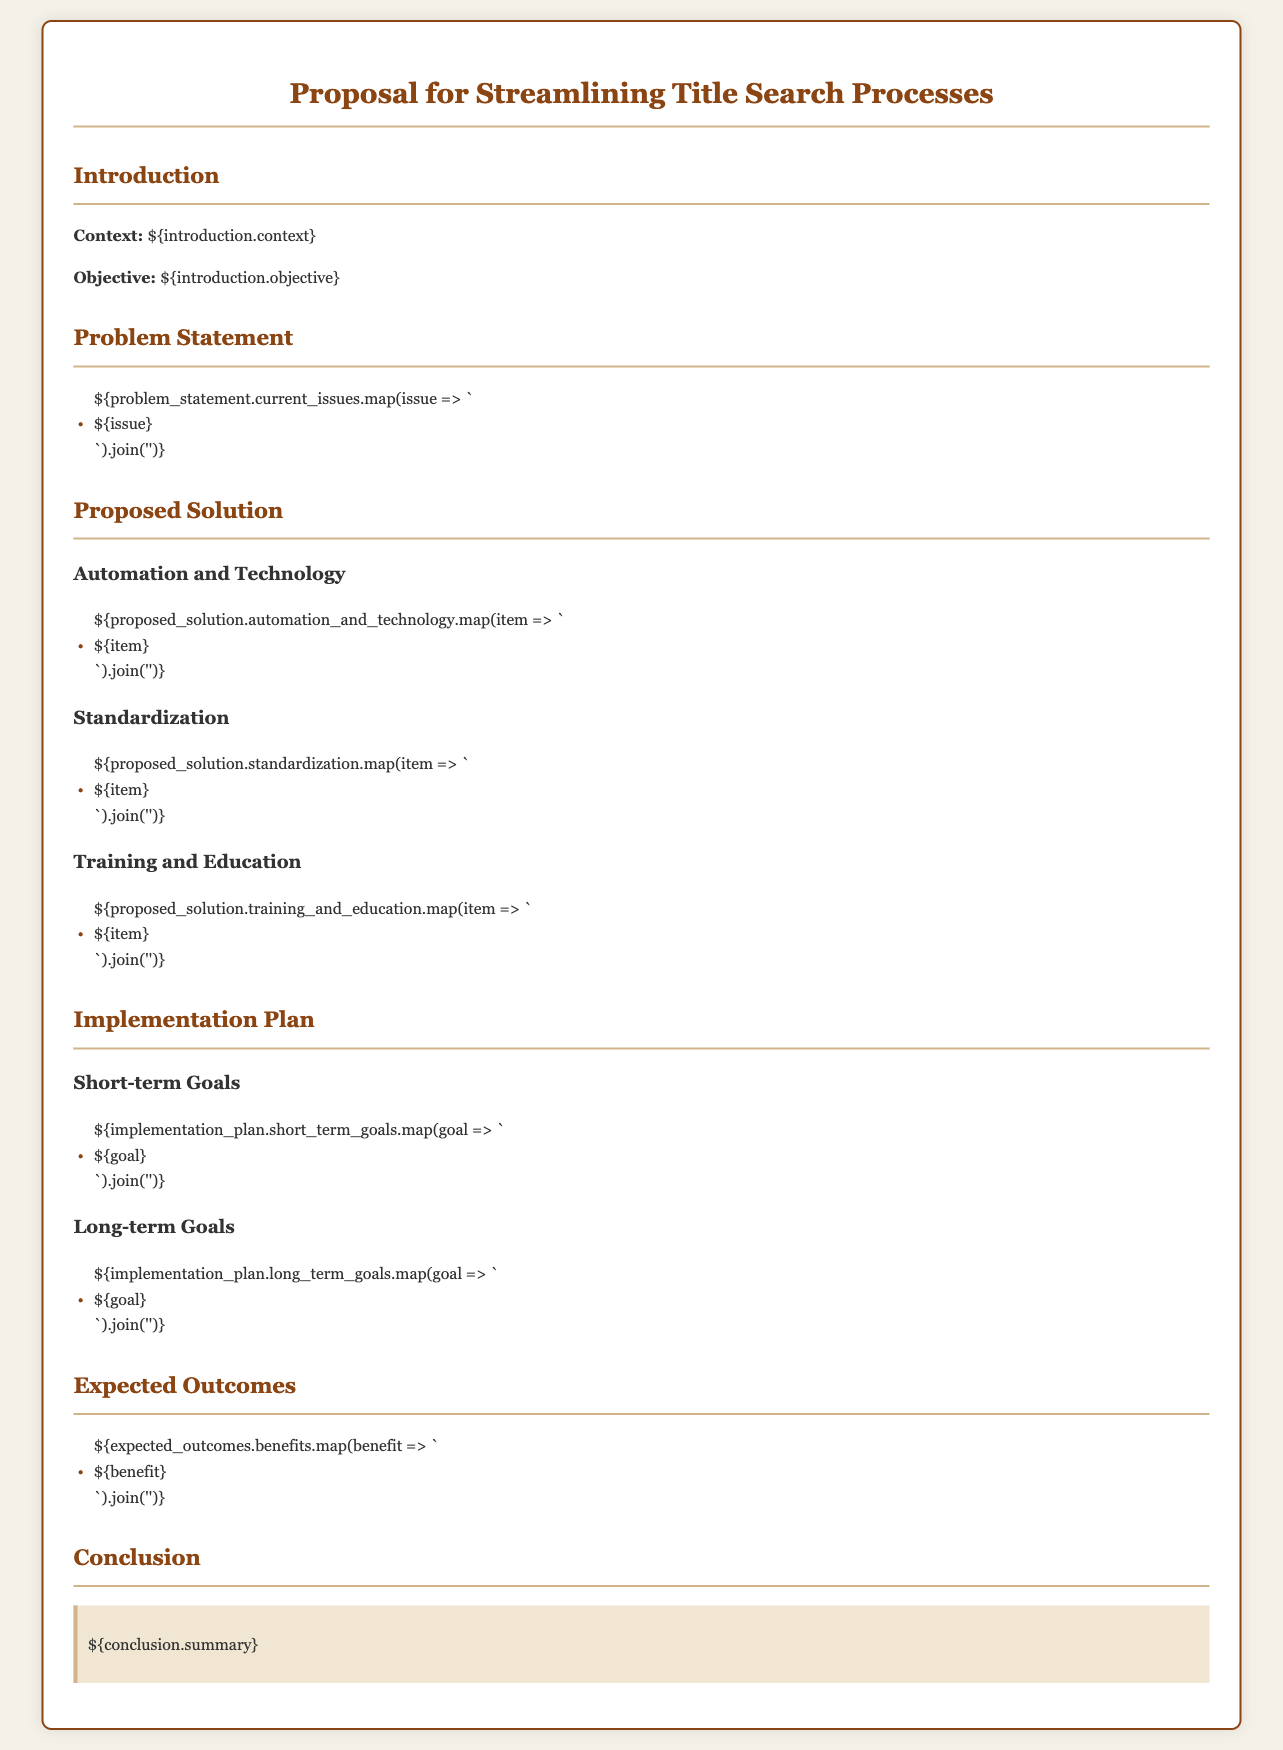What is the title of the proposal? The title of the proposal is found at the top of the document in the main heading.
Answer: Proposal for Streamlining Title Search Processes What is the primary objective of the proposal? The objective is stated in the introduction section of the document.
Answer: Reduce time and errors in property transactions How many short-term goals are outlined in the implementation plan? The number of short-term goals can be counted from the section that lists them.
Answer: [Insert number based on the document] What is one of the proposed solutions related to technology? The proposed solutions under the automation and technology section provide specific options.
Answer: Automation of title searches What is a key benefit expected from the proposed solution? The benefits listed in the expected outcomes section highlight advantages of the proposal.
Answer: Reduced processing time What does the conclusion section summarize? The conclusion section contains a summary of the entire proposal, focusing on the main takeaways.
Answer: A comprehensive approach to streamlining title searches 